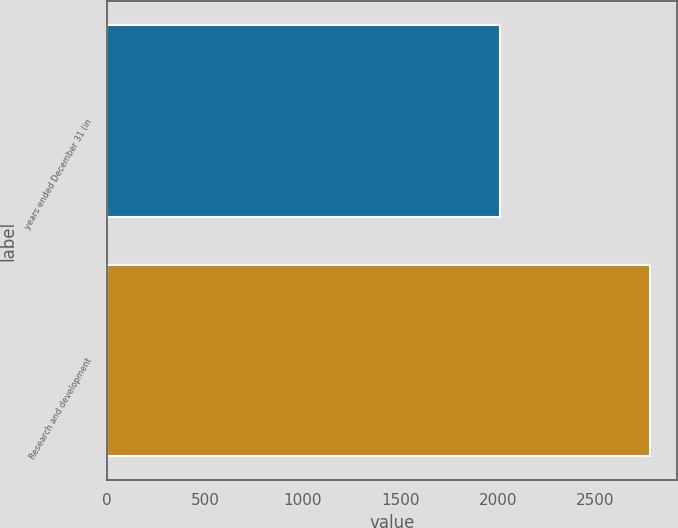Convert chart. <chart><loc_0><loc_0><loc_500><loc_500><bar_chart><fcel>years ended December 31 (in<fcel>Research and development<nl><fcel>2012<fcel>2778<nl></chart> 